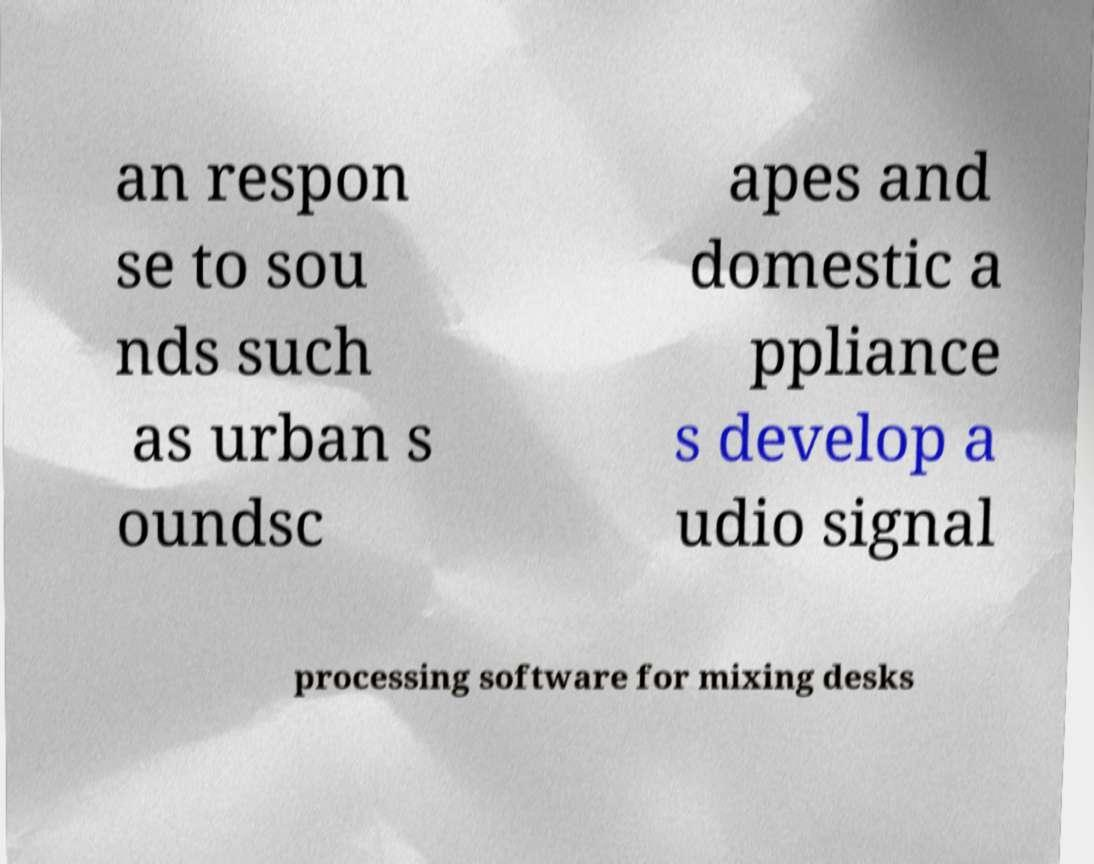Can you read and provide the text displayed in the image?This photo seems to have some interesting text. Can you extract and type it out for me? an respon se to sou nds such as urban s oundsc apes and domestic a ppliance s develop a udio signal processing software for mixing desks 